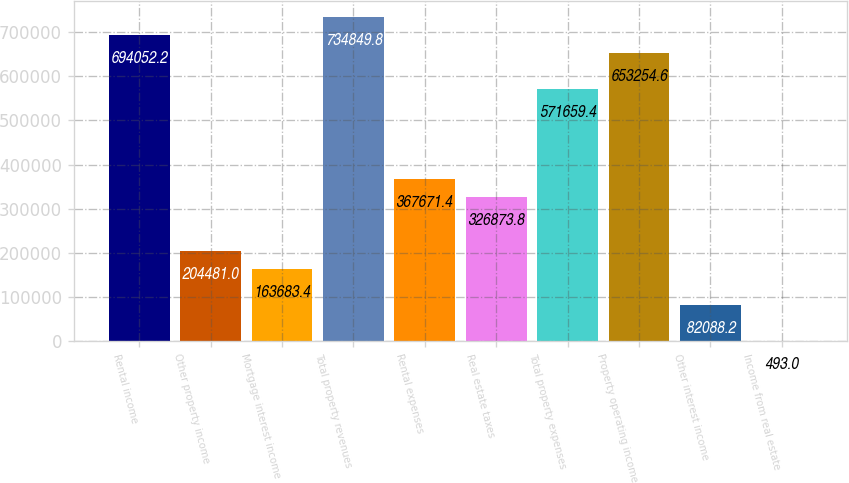<chart> <loc_0><loc_0><loc_500><loc_500><bar_chart><fcel>Rental income<fcel>Other property income<fcel>Mortgage interest income<fcel>Total property revenues<fcel>Rental expenses<fcel>Real estate taxes<fcel>Total property expenses<fcel>Property operating income<fcel>Other interest income<fcel>Income from real estate<nl><fcel>694052<fcel>204481<fcel>163683<fcel>734850<fcel>367671<fcel>326874<fcel>571659<fcel>653255<fcel>82088.2<fcel>493<nl></chart> 